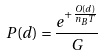Convert formula to latex. <formula><loc_0><loc_0><loc_500><loc_500>P ( d ) = \frac { e ^ { + \frac { O ( d ) } { n _ { B } T } } } { G }</formula> 